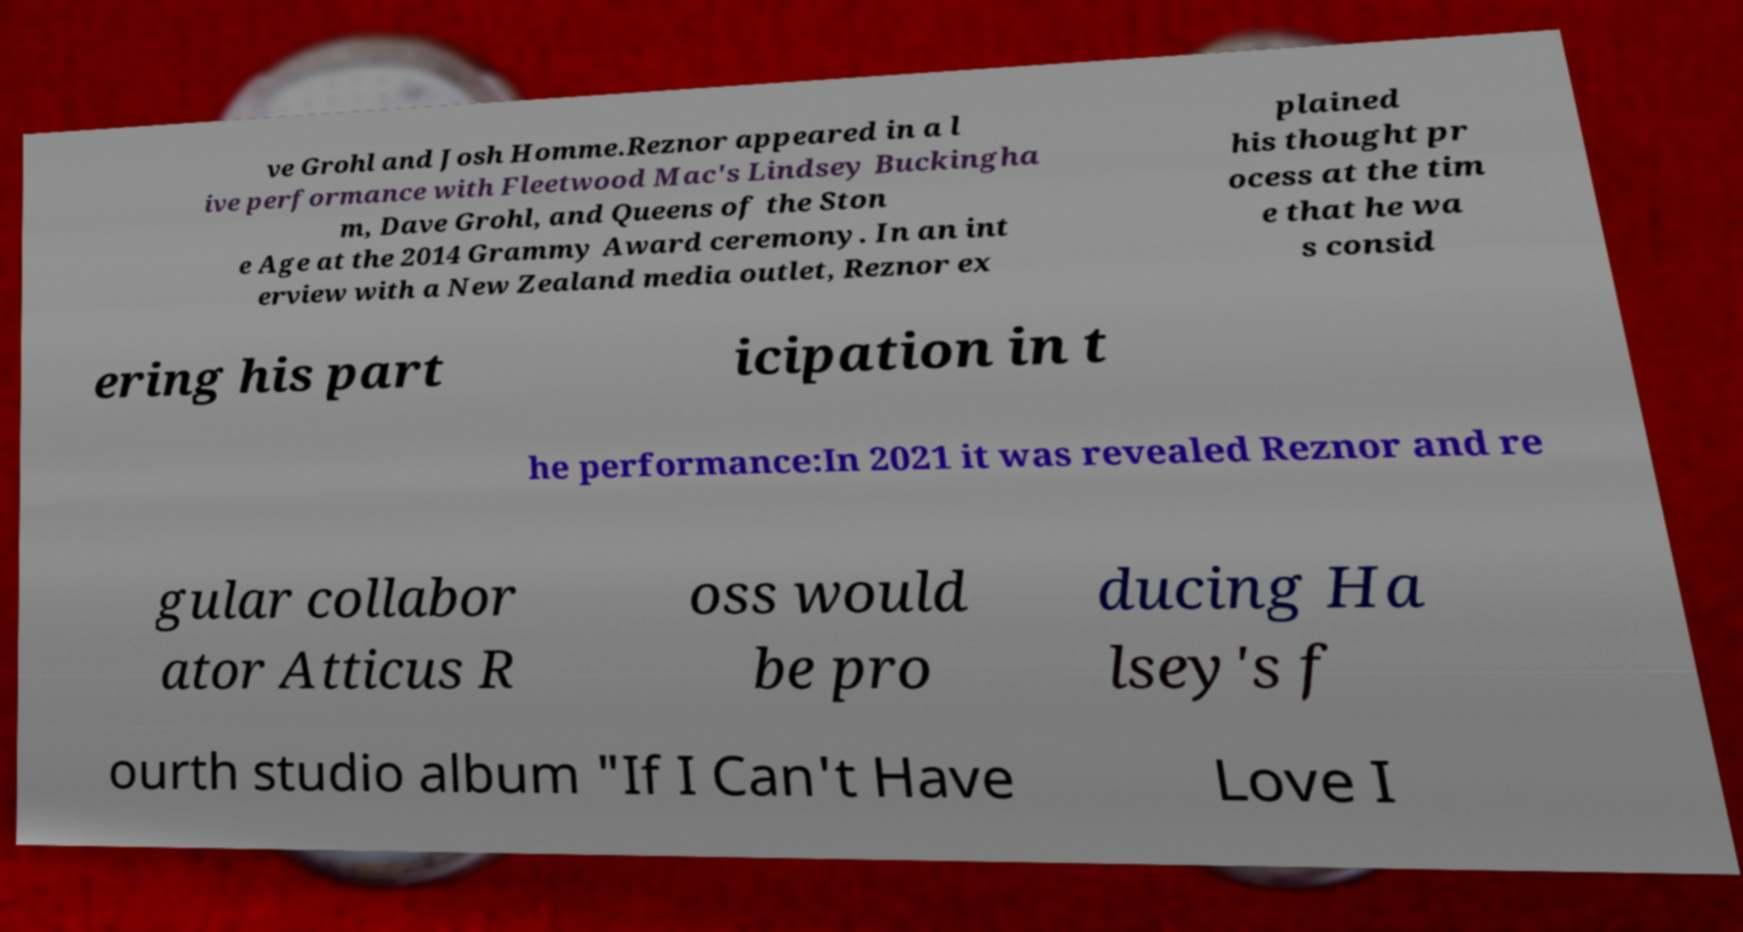Please identify and transcribe the text found in this image. ve Grohl and Josh Homme.Reznor appeared in a l ive performance with Fleetwood Mac's Lindsey Buckingha m, Dave Grohl, and Queens of the Ston e Age at the 2014 Grammy Award ceremony. In an int erview with a New Zealand media outlet, Reznor ex plained his thought pr ocess at the tim e that he wa s consid ering his part icipation in t he performance:In 2021 it was revealed Reznor and re gular collabor ator Atticus R oss would be pro ducing Ha lsey's f ourth studio album "If I Can't Have Love I 